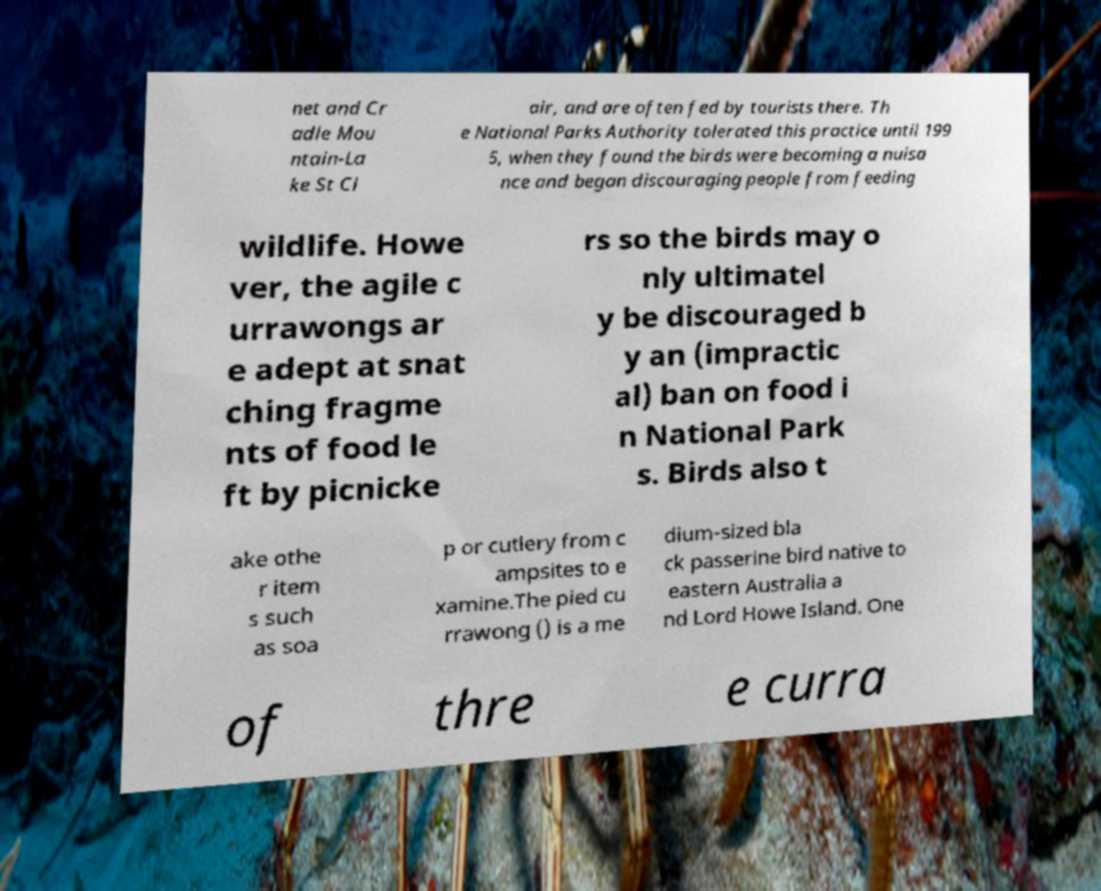Could you extract and type out the text from this image? net and Cr adle Mou ntain-La ke St Cl air, and are often fed by tourists there. Th e National Parks Authority tolerated this practice until 199 5, when they found the birds were becoming a nuisa nce and began discouraging people from feeding wildlife. Howe ver, the agile c urrawongs ar e adept at snat ching fragme nts of food le ft by picnicke rs so the birds may o nly ultimatel y be discouraged b y an (impractic al) ban on food i n National Park s. Birds also t ake othe r item s such as soa p or cutlery from c ampsites to e xamine.The pied cu rrawong () is a me dium-sized bla ck passerine bird native to eastern Australia a nd Lord Howe Island. One of thre e curra 